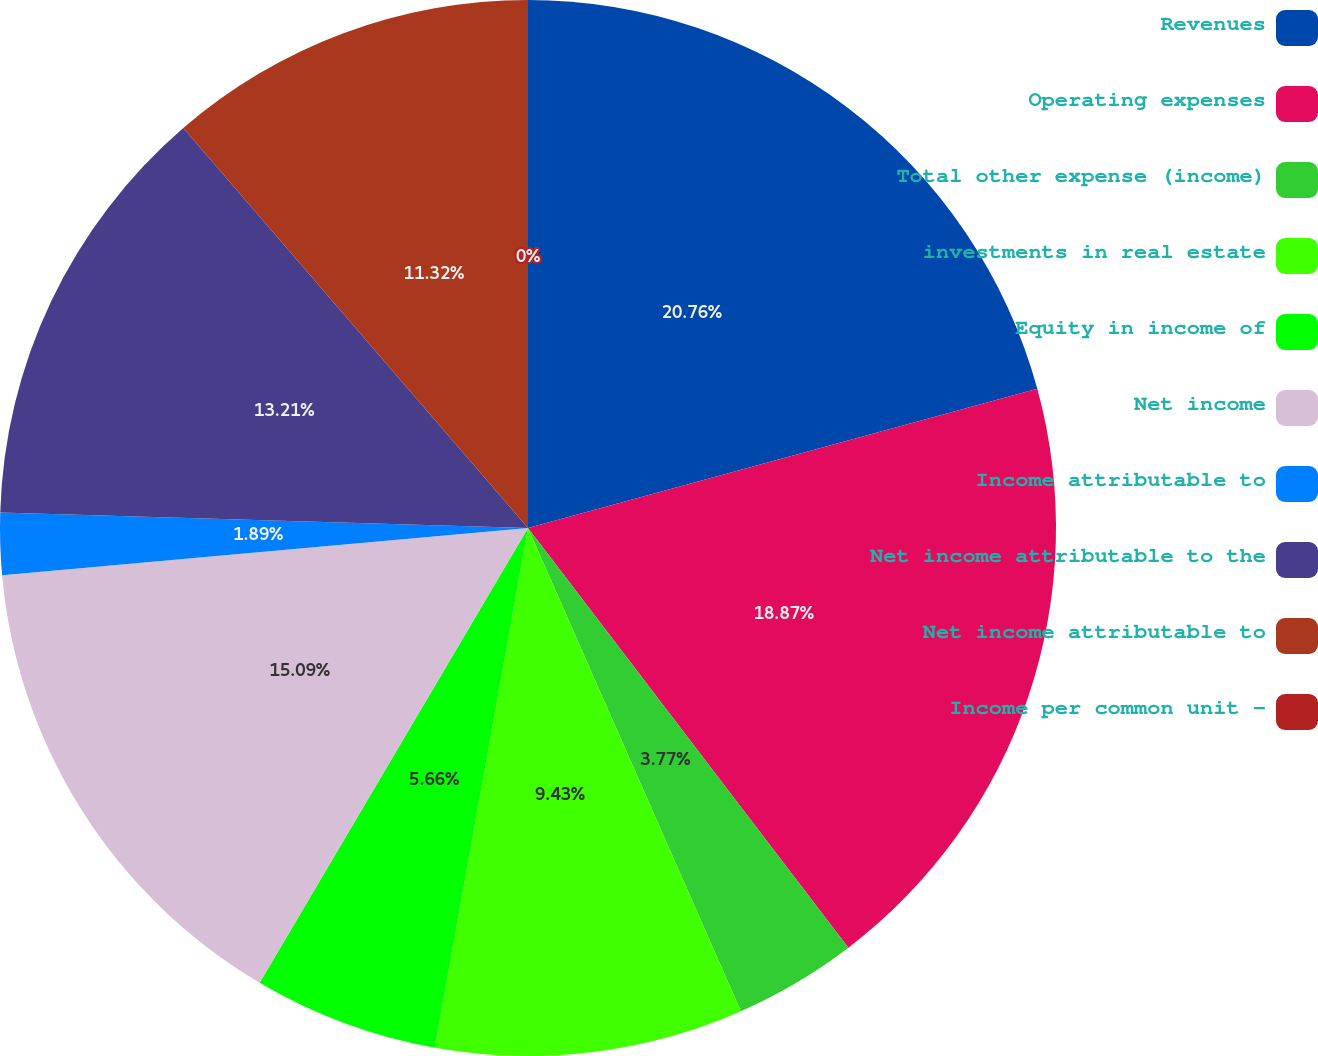<chart> <loc_0><loc_0><loc_500><loc_500><pie_chart><fcel>Revenues<fcel>Operating expenses<fcel>Total other expense (income)<fcel>investments in real estate<fcel>Equity in income of<fcel>Net income<fcel>Income attributable to<fcel>Net income attributable to the<fcel>Net income attributable to<fcel>Income per common unit -<nl><fcel>20.75%<fcel>18.87%<fcel>3.77%<fcel>9.43%<fcel>5.66%<fcel>15.09%<fcel>1.89%<fcel>13.21%<fcel>11.32%<fcel>0.0%<nl></chart> 